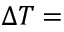<formula> <loc_0><loc_0><loc_500><loc_500>\Delta T =</formula> 